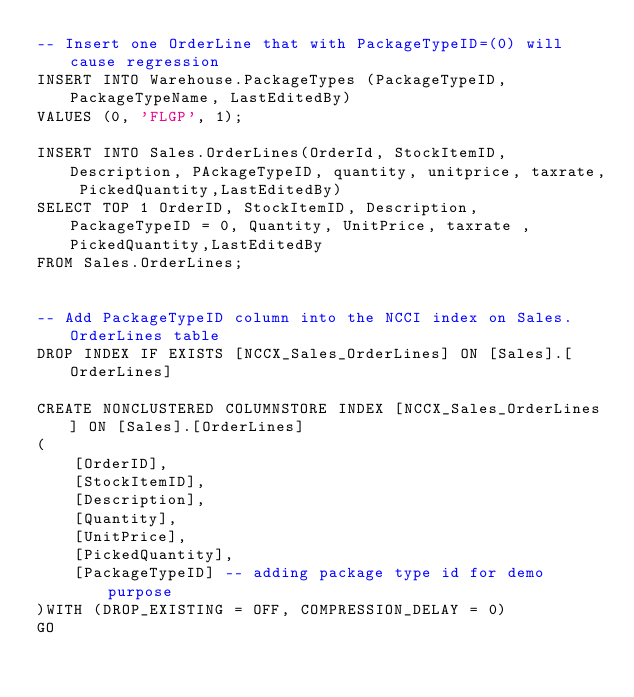<code> <loc_0><loc_0><loc_500><loc_500><_SQL_>-- Insert one OrderLine that with PackageTypeID=(0) will cause regression
INSERT INTO Warehouse.PackageTypes (PackageTypeID, PackageTypeName, LastEditedBy)
VALUES (0, 'FLGP', 1);

INSERT INTO Sales.OrderLines(OrderId, StockItemID, Description, PAckageTypeID, quantity, unitprice, taxrate, PickedQuantity,LastEditedBy)
SELECT TOP 1 OrderID, StockItemID, Description, PackageTypeID = 0, Quantity, UnitPrice, taxrate , PickedQuantity,LastEditedBy
FROM Sales.OrderLines;


-- Add PackageTypeID column into the NCCI index on Sales.OrderLines table
DROP INDEX IF EXISTS [NCCX_Sales_OrderLines] ON [Sales].[OrderLines]

CREATE NONCLUSTERED COLUMNSTORE INDEX [NCCX_Sales_OrderLines] ON [Sales].[OrderLines]
(
	[OrderID],
	[StockItemID],
	[Description],
	[Quantity],
	[UnitPrice],
	[PickedQuantity],
	[PackageTypeID] -- adding package type id for demo purpose
)WITH (DROP_EXISTING = OFF, COMPRESSION_DELAY = 0) 
GO
</code> 